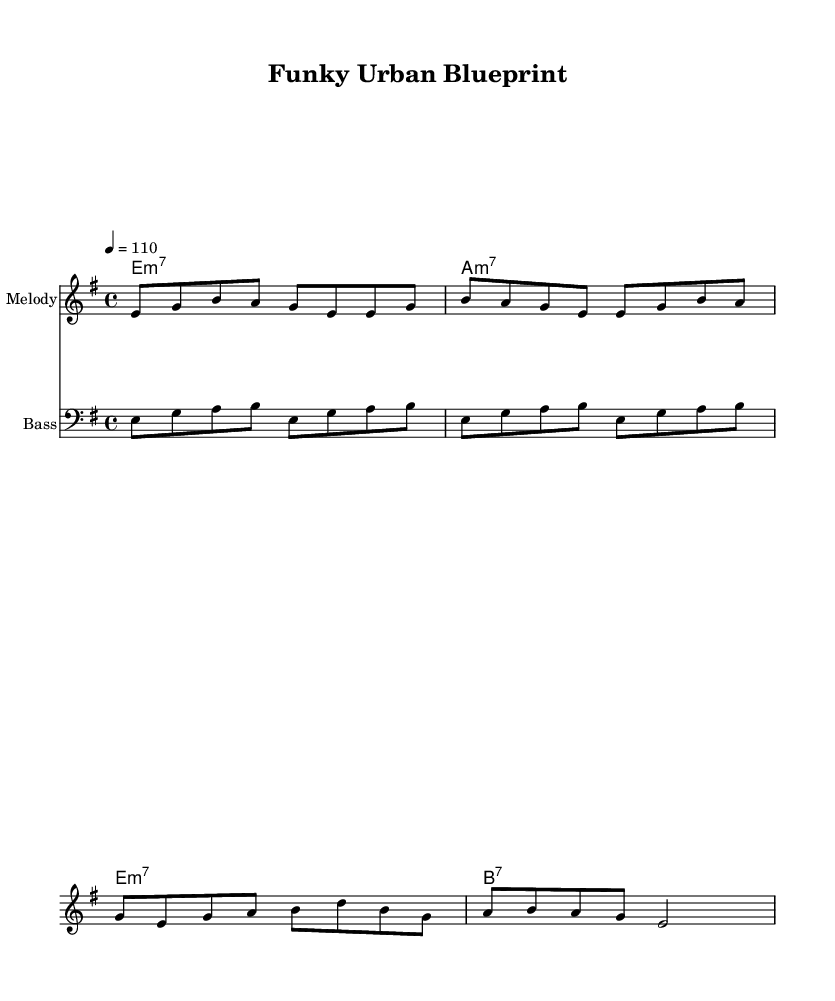What is the key signature of this music? The key signature is E minor, which contains one sharp (F#). This can be identified on the left side of the staff where the key signature is indicated.
Answer: E minor What is the time signature of this music? The time signature is 4/4, which means there are four beats in each measure. This is visually indicated at the beginning of the sheet music, next to the key signature.
Answer: 4/4 What is the tempo marking for this piece? The tempo marking indicates a speed of 110 beats per minute, which is noted at the beginning of the score next to the time signature.
Answer: 110 What is the structure of the melody? The melody consists of phrases that start primarily on E and use notes from the E minor scale. This can be discerned from the melody notes shown in the staff.
Answer: E minor scale How many measures are there in the melody chorus? The melody chorus consists of 4 measures, which can be counted by analyzing the number of groups of notes separated by vertical lines on the staff.
Answer: 4 measures What type of harmony is predominantly used in this funk piece? The harmony features minor 7th chords and dominant 7th chords, which are common in funk music. This can be determined from the chord names indicated underneath the staff.
Answer: Minor 7th and dominant 7th 